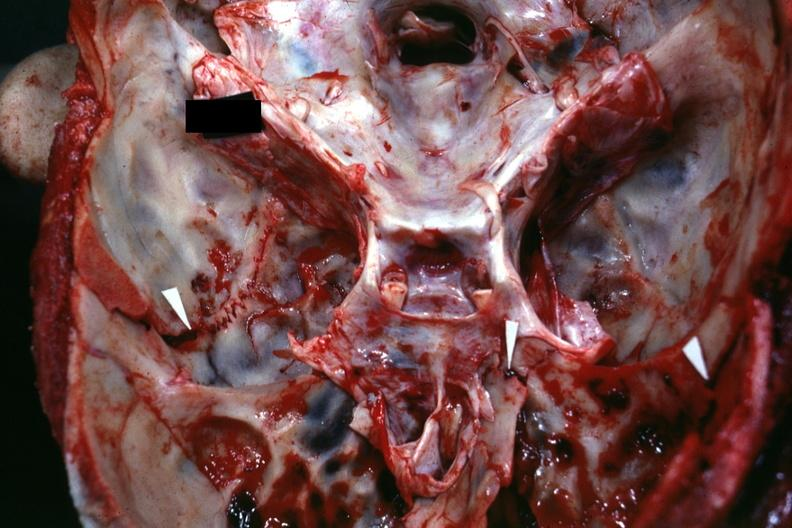what does this image show?
Answer the question using a single word or phrase. Close-up view of base of skull with several well shown fractures 